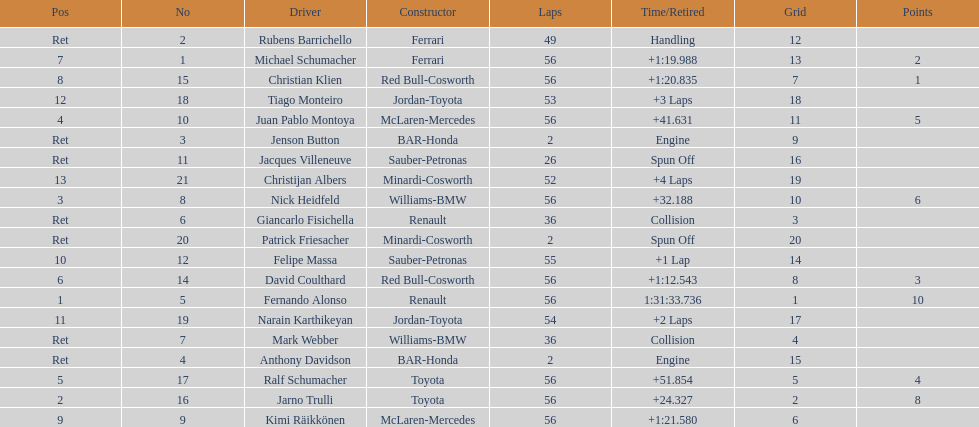How many bmws concluded before webber? 1. 